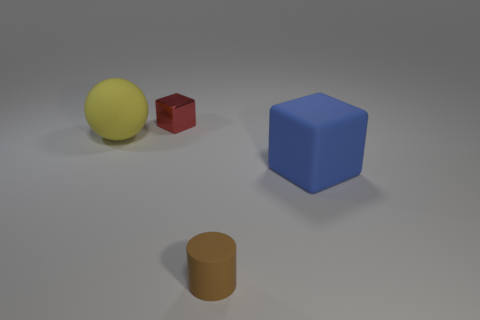Do the large object to the left of the brown rubber thing and the small object behind the large blue object have the same shape?
Provide a short and direct response. No. How many things are purple metallic cubes or things that are right of the big yellow object?
Your answer should be very brief. 3. How many other objects are there of the same size as the ball?
Offer a very short reply. 1. Does the object in front of the blue rubber block have the same material as the tiny object to the left of the small brown rubber cylinder?
Provide a succinct answer. No. What number of red metallic cubes are right of the big yellow ball?
Your answer should be very brief. 1. What number of cyan objects are either big things or metal cylinders?
Provide a succinct answer. 0. What is the material of the yellow object that is the same size as the blue matte block?
Make the answer very short. Rubber. There is a object that is behind the rubber cylinder and on the right side of the small red block; what shape is it?
Keep it short and to the point. Cube. What is the color of the cube that is the same size as the rubber cylinder?
Your answer should be compact. Red. There is a block on the right side of the tiny cylinder; is its size the same as the cube left of the cylinder?
Give a very brief answer. No. 